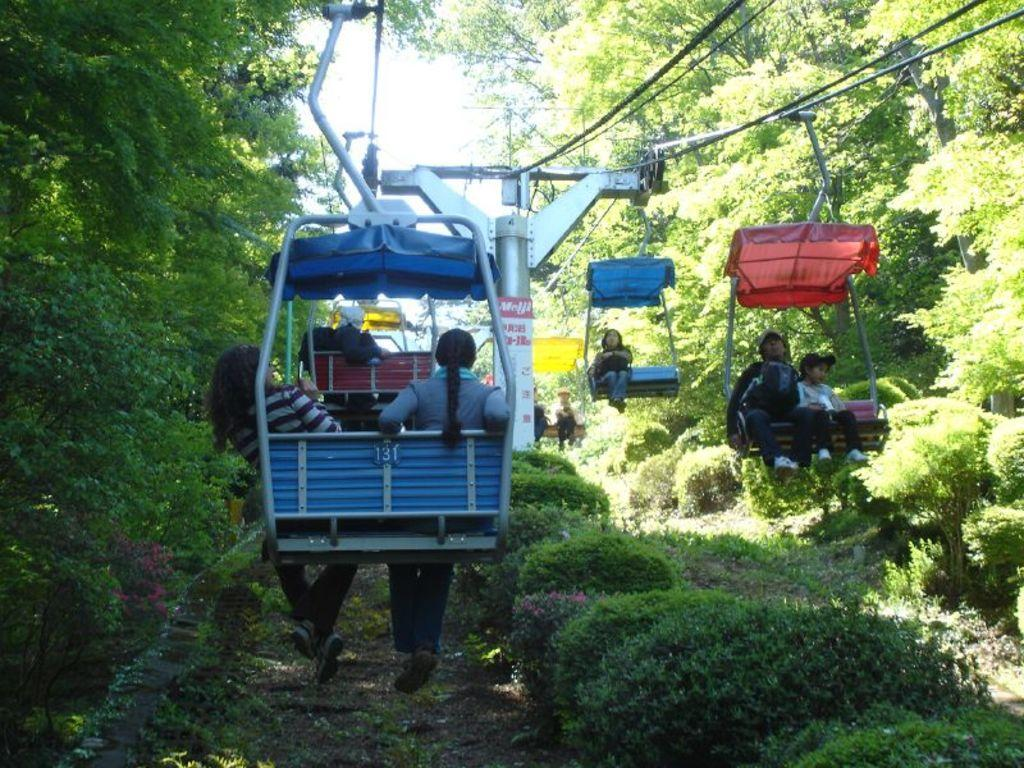What are the people in the image doing? The people in the image are sitting on the rope way. What can be seen in the image besides the people? There is a pole, ropes, wires, plants, trees, and the sky visible in the image. What type of songs can be heard being sung by the horses in the image? There are no horses present in the image, so there are no songs being sung by them. 